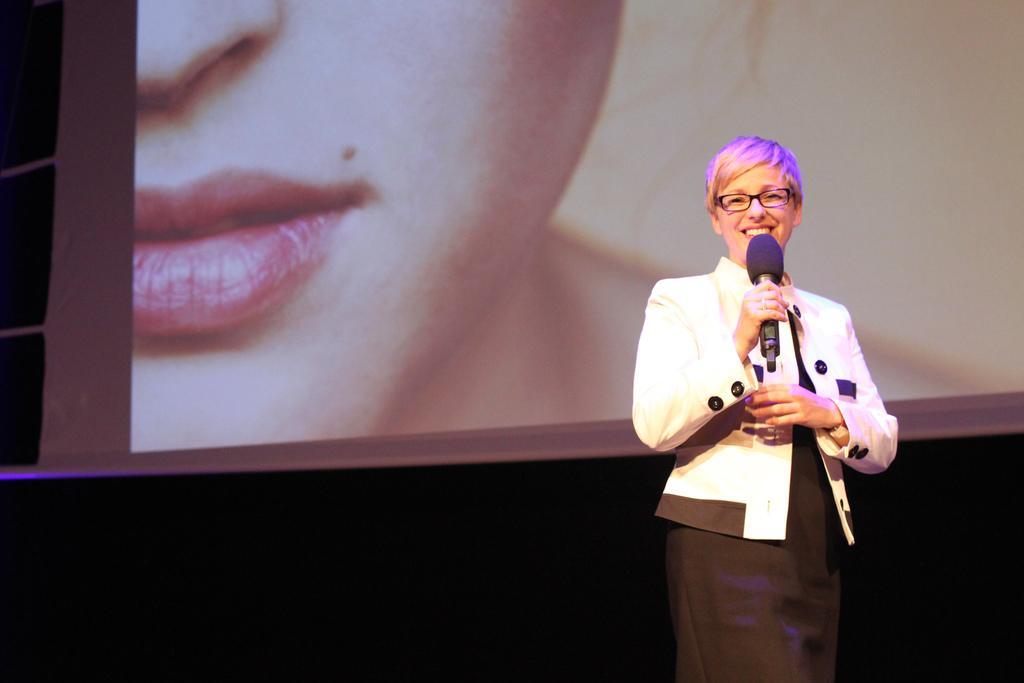What is the woman in the image holding? The woman is holding a mic. What is the woman's facial expression in the image? The woman is smiling. What can be seen in the background of the image? There is a screen in the background of the image, and a person's face is visible but truncated. What type of snakes can be seen slithering on the floor in the image? There are no snakes present in the image. What kind of engine is visible in the background of the image? There is no engine visible in the image; it features a woman holding a mic, a screen in the background, and a truncated face. 